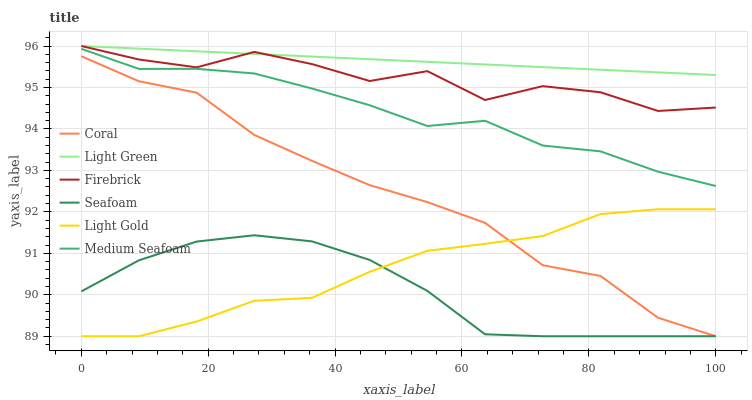Does Seafoam have the minimum area under the curve?
Answer yes or no. Yes. Does Light Green have the maximum area under the curve?
Answer yes or no. Yes. Does Firebrick have the minimum area under the curve?
Answer yes or no. No. Does Firebrick have the maximum area under the curve?
Answer yes or no. No. Is Light Green the smoothest?
Answer yes or no. Yes. Is Firebrick the roughest?
Answer yes or no. Yes. Is Seafoam the smoothest?
Answer yes or no. No. Is Seafoam the roughest?
Answer yes or no. No. Does Coral have the lowest value?
Answer yes or no. Yes. Does Firebrick have the lowest value?
Answer yes or no. No. Does Light Green have the highest value?
Answer yes or no. Yes. Does Seafoam have the highest value?
Answer yes or no. No. Is Coral less than Medium Seafoam?
Answer yes or no. Yes. Is Medium Seafoam greater than Coral?
Answer yes or no. Yes. Does Light Gold intersect Seafoam?
Answer yes or no. Yes. Is Light Gold less than Seafoam?
Answer yes or no. No. Is Light Gold greater than Seafoam?
Answer yes or no. No. Does Coral intersect Medium Seafoam?
Answer yes or no. No. 